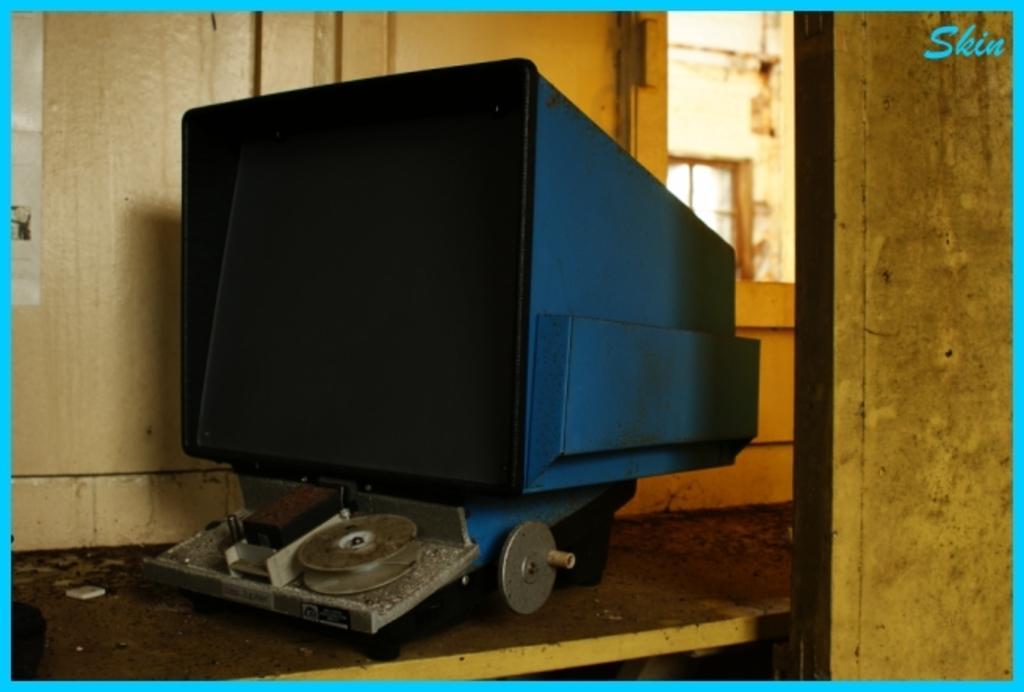Describe this image in one or two sentences. In this image we can see a machine on the wooden surface. In the background, we can see a wall and a window. It seems like a door on the right side of the image. 